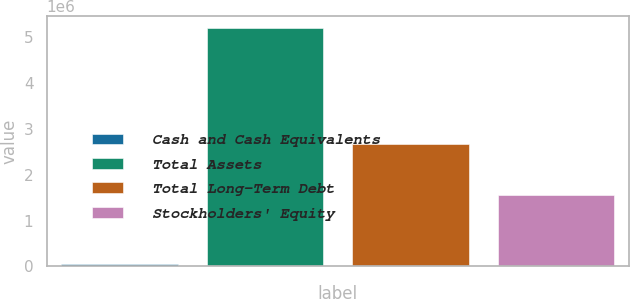Convert chart to OTSL. <chart><loc_0><loc_0><loc_500><loc_500><bar_chart><fcel>Cash and Cash Equivalents<fcel>Total Assets<fcel>Total Long-Term Debt<fcel>Stockholders' Equity<nl><fcel>45369<fcel>5.20952e+06<fcel>2.66882e+06<fcel>1.55327e+06<nl></chart> 